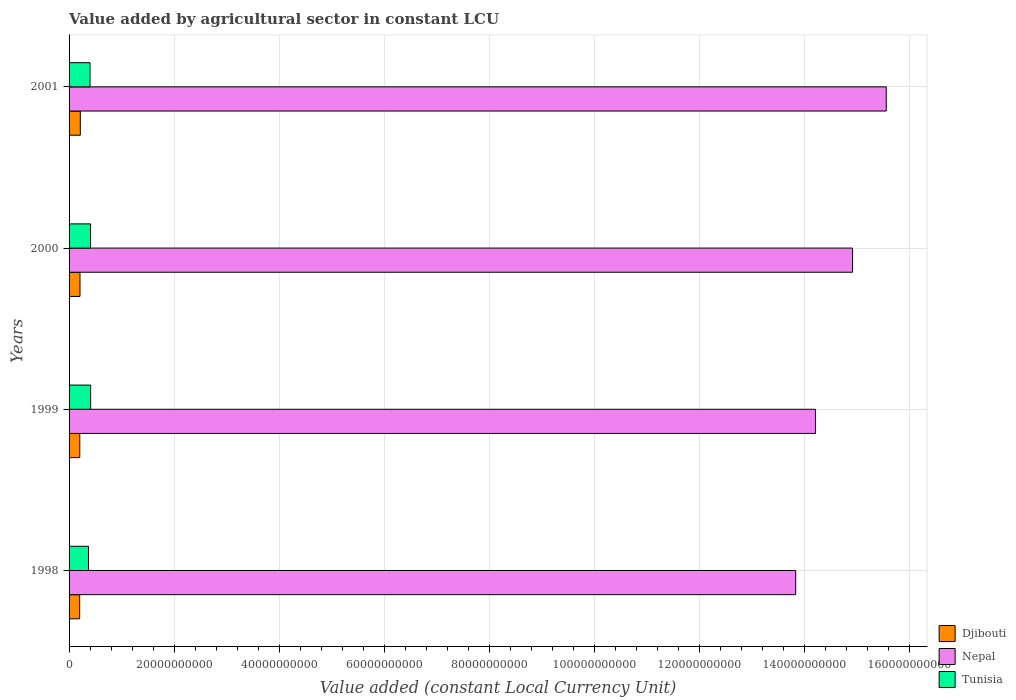How many groups of bars are there?
Keep it short and to the point. 4. Are the number of bars per tick equal to the number of legend labels?
Your response must be concise. Yes. Are the number of bars on each tick of the Y-axis equal?
Provide a succinct answer. Yes. How many bars are there on the 2nd tick from the top?
Your answer should be very brief. 3. In how many cases, is the number of bars for a given year not equal to the number of legend labels?
Your answer should be compact. 0. What is the value added by agricultural sector in Tunisia in 2000?
Provide a short and direct response. 4.09e+09. Across all years, what is the maximum value added by agricultural sector in Nepal?
Give a very brief answer. 1.56e+11. Across all years, what is the minimum value added by agricultural sector in Djibouti?
Offer a very short reply. 2.02e+09. What is the total value added by agricultural sector in Nepal in the graph?
Your answer should be very brief. 5.85e+11. What is the difference between the value added by agricultural sector in Djibouti in 1999 and that in 2000?
Offer a very short reply. -3.78e+07. What is the difference between the value added by agricultural sector in Djibouti in 2000 and the value added by agricultural sector in Tunisia in 1999?
Provide a succinct answer. -2.03e+09. What is the average value added by agricultural sector in Nepal per year?
Your answer should be compact. 1.46e+11. In the year 2001, what is the difference between the value added by agricultural sector in Djibouti and value added by agricultural sector in Tunisia?
Make the answer very short. -1.85e+09. In how many years, is the value added by agricultural sector in Tunisia greater than 148000000000 LCU?
Offer a very short reply. 0. What is the ratio of the value added by agricultural sector in Tunisia in 1999 to that in 2000?
Give a very brief answer. 1. Is the value added by agricultural sector in Tunisia in 1998 less than that in 2000?
Ensure brevity in your answer.  Yes. What is the difference between the highest and the second highest value added by agricultural sector in Djibouti?
Make the answer very short. 6.23e+07. What is the difference between the highest and the lowest value added by agricultural sector in Nepal?
Offer a terse response. 1.72e+1. What does the 2nd bar from the top in 2001 represents?
Give a very brief answer. Nepal. What does the 3rd bar from the bottom in 2000 represents?
Provide a succinct answer. Tunisia. Is it the case that in every year, the sum of the value added by agricultural sector in Tunisia and value added by agricultural sector in Djibouti is greater than the value added by agricultural sector in Nepal?
Provide a short and direct response. No. How many bars are there?
Keep it short and to the point. 12. Are all the bars in the graph horizontal?
Your answer should be very brief. Yes. How many years are there in the graph?
Offer a terse response. 4. Does the graph contain any zero values?
Give a very brief answer. No. How many legend labels are there?
Give a very brief answer. 3. How are the legend labels stacked?
Provide a succinct answer. Vertical. What is the title of the graph?
Provide a short and direct response. Value added by agricultural sector in constant LCU. Does "United Arab Emirates" appear as one of the legend labels in the graph?
Your response must be concise. No. What is the label or title of the X-axis?
Your response must be concise. Value added (constant Local Currency Unit). What is the label or title of the Y-axis?
Provide a short and direct response. Years. What is the Value added (constant Local Currency Unit) of Djibouti in 1998?
Provide a short and direct response. 2.02e+09. What is the Value added (constant Local Currency Unit) of Nepal in 1998?
Keep it short and to the point. 1.38e+11. What is the Value added (constant Local Currency Unit) of Tunisia in 1998?
Your answer should be compact. 3.70e+09. What is the Value added (constant Local Currency Unit) in Djibouti in 1999?
Your response must be concise. 2.04e+09. What is the Value added (constant Local Currency Unit) in Nepal in 1999?
Give a very brief answer. 1.42e+11. What is the Value added (constant Local Currency Unit) in Tunisia in 1999?
Keep it short and to the point. 4.11e+09. What is the Value added (constant Local Currency Unit) in Djibouti in 2000?
Your answer should be very brief. 2.08e+09. What is the Value added (constant Local Currency Unit) of Nepal in 2000?
Your response must be concise. 1.49e+11. What is the Value added (constant Local Currency Unit) of Tunisia in 2000?
Your response must be concise. 4.09e+09. What is the Value added (constant Local Currency Unit) in Djibouti in 2001?
Your response must be concise. 2.14e+09. What is the Value added (constant Local Currency Unit) of Nepal in 2001?
Make the answer very short. 1.56e+11. What is the Value added (constant Local Currency Unit) of Tunisia in 2001?
Provide a succinct answer. 3.99e+09. Across all years, what is the maximum Value added (constant Local Currency Unit) in Djibouti?
Keep it short and to the point. 2.14e+09. Across all years, what is the maximum Value added (constant Local Currency Unit) of Nepal?
Offer a terse response. 1.56e+11. Across all years, what is the maximum Value added (constant Local Currency Unit) of Tunisia?
Offer a very short reply. 4.11e+09. Across all years, what is the minimum Value added (constant Local Currency Unit) of Djibouti?
Keep it short and to the point. 2.02e+09. Across all years, what is the minimum Value added (constant Local Currency Unit) in Nepal?
Ensure brevity in your answer.  1.38e+11. Across all years, what is the minimum Value added (constant Local Currency Unit) in Tunisia?
Offer a very short reply. 3.70e+09. What is the total Value added (constant Local Currency Unit) in Djibouti in the graph?
Give a very brief answer. 8.28e+09. What is the total Value added (constant Local Currency Unit) in Nepal in the graph?
Your answer should be very brief. 5.85e+11. What is the total Value added (constant Local Currency Unit) in Tunisia in the graph?
Your answer should be very brief. 1.59e+1. What is the difference between the Value added (constant Local Currency Unit) in Djibouti in 1998 and that in 1999?
Your answer should be very brief. -1.97e+07. What is the difference between the Value added (constant Local Currency Unit) in Nepal in 1998 and that in 1999?
Offer a terse response. -3.76e+09. What is the difference between the Value added (constant Local Currency Unit) in Tunisia in 1998 and that in 1999?
Provide a succinct answer. -4.07e+08. What is the difference between the Value added (constant Local Currency Unit) of Djibouti in 1998 and that in 2000?
Provide a succinct answer. -5.75e+07. What is the difference between the Value added (constant Local Currency Unit) of Nepal in 1998 and that in 2000?
Your response must be concise. -1.08e+1. What is the difference between the Value added (constant Local Currency Unit) of Tunisia in 1998 and that in 2000?
Provide a succinct answer. -3.91e+08. What is the difference between the Value added (constant Local Currency Unit) in Djibouti in 1998 and that in 2001?
Your answer should be very brief. -1.20e+08. What is the difference between the Value added (constant Local Currency Unit) in Nepal in 1998 and that in 2001?
Your answer should be compact. -1.72e+1. What is the difference between the Value added (constant Local Currency Unit) of Tunisia in 1998 and that in 2001?
Make the answer very short. -2.86e+08. What is the difference between the Value added (constant Local Currency Unit) in Djibouti in 1999 and that in 2000?
Ensure brevity in your answer.  -3.78e+07. What is the difference between the Value added (constant Local Currency Unit) of Nepal in 1999 and that in 2000?
Ensure brevity in your answer.  -7.06e+09. What is the difference between the Value added (constant Local Currency Unit) in Tunisia in 1999 and that in 2000?
Your response must be concise. 1.57e+07. What is the difference between the Value added (constant Local Currency Unit) in Djibouti in 1999 and that in 2001?
Your answer should be very brief. -1.00e+08. What is the difference between the Value added (constant Local Currency Unit) of Nepal in 1999 and that in 2001?
Your answer should be compact. -1.35e+1. What is the difference between the Value added (constant Local Currency Unit) of Tunisia in 1999 and that in 2001?
Give a very brief answer. 1.20e+08. What is the difference between the Value added (constant Local Currency Unit) of Djibouti in 2000 and that in 2001?
Ensure brevity in your answer.  -6.23e+07. What is the difference between the Value added (constant Local Currency Unit) of Nepal in 2000 and that in 2001?
Offer a very short reply. -6.42e+09. What is the difference between the Value added (constant Local Currency Unit) of Tunisia in 2000 and that in 2001?
Provide a succinct answer. 1.05e+08. What is the difference between the Value added (constant Local Currency Unit) of Djibouti in 1998 and the Value added (constant Local Currency Unit) of Nepal in 1999?
Keep it short and to the point. -1.40e+11. What is the difference between the Value added (constant Local Currency Unit) in Djibouti in 1998 and the Value added (constant Local Currency Unit) in Tunisia in 1999?
Your response must be concise. -2.09e+09. What is the difference between the Value added (constant Local Currency Unit) of Nepal in 1998 and the Value added (constant Local Currency Unit) of Tunisia in 1999?
Make the answer very short. 1.34e+11. What is the difference between the Value added (constant Local Currency Unit) in Djibouti in 1998 and the Value added (constant Local Currency Unit) in Nepal in 2000?
Keep it short and to the point. -1.47e+11. What is the difference between the Value added (constant Local Currency Unit) of Djibouti in 1998 and the Value added (constant Local Currency Unit) of Tunisia in 2000?
Provide a succinct answer. -2.07e+09. What is the difference between the Value added (constant Local Currency Unit) of Nepal in 1998 and the Value added (constant Local Currency Unit) of Tunisia in 2000?
Offer a terse response. 1.34e+11. What is the difference between the Value added (constant Local Currency Unit) of Djibouti in 1998 and the Value added (constant Local Currency Unit) of Nepal in 2001?
Your answer should be compact. -1.54e+11. What is the difference between the Value added (constant Local Currency Unit) of Djibouti in 1998 and the Value added (constant Local Currency Unit) of Tunisia in 2001?
Your answer should be compact. -1.97e+09. What is the difference between the Value added (constant Local Currency Unit) of Nepal in 1998 and the Value added (constant Local Currency Unit) of Tunisia in 2001?
Make the answer very short. 1.34e+11. What is the difference between the Value added (constant Local Currency Unit) in Djibouti in 1999 and the Value added (constant Local Currency Unit) in Nepal in 2000?
Make the answer very short. -1.47e+11. What is the difference between the Value added (constant Local Currency Unit) of Djibouti in 1999 and the Value added (constant Local Currency Unit) of Tunisia in 2000?
Your answer should be very brief. -2.05e+09. What is the difference between the Value added (constant Local Currency Unit) of Nepal in 1999 and the Value added (constant Local Currency Unit) of Tunisia in 2000?
Provide a short and direct response. 1.38e+11. What is the difference between the Value added (constant Local Currency Unit) of Djibouti in 1999 and the Value added (constant Local Currency Unit) of Nepal in 2001?
Your response must be concise. -1.54e+11. What is the difference between the Value added (constant Local Currency Unit) of Djibouti in 1999 and the Value added (constant Local Currency Unit) of Tunisia in 2001?
Your response must be concise. -1.95e+09. What is the difference between the Value added (constant Local Currency Unit) in Nepal in 1999 and the Value added (constant Local Currency Unit) in Tunisia in 2001?
Make the answer very short. 1.38e+11. What is the difference between the Value added (constant Local Currency Unit) in Djibouti in 2000 and the Value added (constant Local Currency Unit) in Nepal in 2001?
Your answer should be very brief. -1.54e+11. What is the difference between the Value added (constant Local Currency Unit) of Djibouti in 2000 and the Value added (constant Local Currency Unit) of Tunisia in 2001?
Ensure brevity in your answer.  -1.91e+09. What is the difference between the Value added (constant Local Currency Unit) of Nepal in 2000 and the Value added (constant Local Currency Unit) of Tunisia in 2001?
Offer a very short reply. 1.45e+11. What is the average Value added (constant Local Currency Unit) of Djibouti per year?
Give a very brief answer. 2.07e+09. What is the average Value added (constant Local Currency Unit) in Nepal per year?
Give a very brief answer. 1.46e+11. What is the average Value added (constant Local Currency Unit) in Tunisia per year?
Provide a short and direct response. 3.97e+09. In the year 1998, what is the difference between the Value added (constant Local Currency Unit) in Djibouti and Value added (constant Local Currency Unit) in Nepal?
Make the answer very short. -1.36e+11. In the year 1998, what is the difference between the Value added (constant Local Currency Unit) in Djibouti and Value added (constant Local Currency Unit) in Tunisia?
Make the answer very short. -1.68e+09. In the year 1998, what is the difference between the Value added (constant Local Currency Unit) in Nepal and Value added (constant Local Currency Unit) in Tunisia?
Your answer should be compact. 1.35e+11. In the year 1999, what is the difference between the Value added (constant Local Currency Unit) in Djibouti and Value added (constant Local Currency Unit) in Nepal?
Give a very brief answer. -1.40e+11. In the year 1999, what is the difference between the Value added (constant Local Currency Unit) in Djibouti and Value added (constant Local Currency Unit) in Tunisia?
Offer a very short reply. -2.07e+09. In the year 1999, what is the difference between the Value added (constant Local Currency Unit) of Nepal and Value added (constant Local Currency Unit) of Tunisia?
Keep it short and to the point. 1.38e+11. In the year 2000, what is the difference between the Value added (constant Local Currency Unit) of Djibouti and Value added (constant Local Currency Unit) of Nepal?
Keep it short and to the point. -1.47e+11. In the year 2000, what is the difference between the Value added (constant Local Currency Unit) in Djibouti and Value added (constant Local Currency Unit) in Tunisia?
Provide a short and direct response. -2.01e+09. In the year 2000, what is the difference between the Value added (constant Local Currency Unit) in Nepal and Value added (constant Local Currency Unit) in Tunisia?
Keep it short and to the point. 1.45e+11. In the year 2001, what is the difference between the Value added (constant Local Currency Unit) in Djibouti and Value added (constant Local Currency Unit) in Nepal?
Your response must be concise. -1.53e+11. In the year 2001, what is the difference between the Value added (constant Local Currency Unit) of Djibouti and Value added (constant Local Currency Unit) of Tunisia?
Provide a short and direct response. -1.85e+09. In the year 2001, what is the difference between the Value added (constant Local Currency Unit) in Nepal and Value added (constant Local Currency Unit) in Tunisia?
Provide a succinct answer. 1.52e+11. What is the ratio of the Value added (constant Local Currency Unit) in Nepal in 1998 to that in 1999?
Offer a very short reply. 0.97. What is the ratio of the Value added (constant Local Currency Unit) of Tunisia in 1998 to that in 1999?
Keep it short and to the point. 0.9. What is the ratio of the Value added (constant Local Currency Unit) of Djibouti in 1998 to that in 2000?
Make the answer very short. 0.97. What is the ratio of the Value added (constant Local Currency Unit) in Nepal in 1998 to that in 2000?
Your response must be concise. 0.93. What is the ratio of the Value added (constant Local Currency Unit) of Tunisia in 1998 to that in 2000?
Provide a succinct answer. 0.9. What is the ratio of the Value added (constant Local Currency Unit) of Djibouti in 1998 to that in 2001?
Offer a terse response. 0.94. What is the ratio of the Value added (constant Local Currency Unit) in Nepal in 1998 to that in 2001?
Your response must be concise. 0.89. What is the ratio of the Value added (constant Local Currency Unit) of Tunisia in 1998 to that in 2001?
Your response must be concise. 0.93. What is the ratio of the Value added (constant Local Currency Unit) in Djibouti in 1999 to that in 2000?
Your answer should be compact. 0.98. What is the ratio of the Value added (constant Local Currency Unit) of Nepal in 1999 to that in 2000?
Ensure brevity in your answer.  0.95. What is the ratio of the Value added (constant Local Currency Unit) in Tunisia in 1999 to that in 2000?
Your response must be concise. 1. What is the ratio of the Value added (constant Local Currency Unit) in Djibouti in 1999 to that in 2001?
Offer a terse response. 0.95. What is the ratio of the Value added (constant Local Currency Unit) of Nepal in 1999 to that in 2001?
Keep it short and to the point. 0.91. What is the ratio of the Value added (constant Local Currency Unit) in Tunisia in 1999 to that in 2001?
Your response must be concise. 1.03. What is the ratio of the Value added (constant Local Currency Unit) of Djibouti in 2000 to that in 2001?
Provide a short and direct response. 0.97. What is the ratio of the Value added (constant Local Currency Unit) in Nepal in 2000 to that in 2001?
Provide a succinct answer. 0.96. What is the ratio of the Value added (constant Local Currency Unit) of Tunisia in 2000 to that in 2001?
Make the answer very short. 1.03. What is the difference between the highest and the second highest Value added (constant Local Currency Unit) in Djibouti?
Offer a terse response. 6.23e+07. What is the difference between the highest and the second highest Value added (constant Local Currency Unit) of Nepal?
Keep it short and to the point. 6.42e+09. What is the difference between the highest and the second highest Value added (constant Local Currency Unit) of Tunisia?
Offer a terse response. 1.57e+07. What is the difference between the highest and the lowest Value added (constant Local Currency Unit) in Djibouti?
Your answer should be very brief. 1.20e+08. What is the difference between the highest and the lowest Value added (constant Local Currency Unit) in Nepal?
Your response must be concise. 1.72e+1. What is the difference between the highest and the lowest Value added (constant Local Currency Unit) of Tunisia?
Make the answer very short. 4.07e+08. 